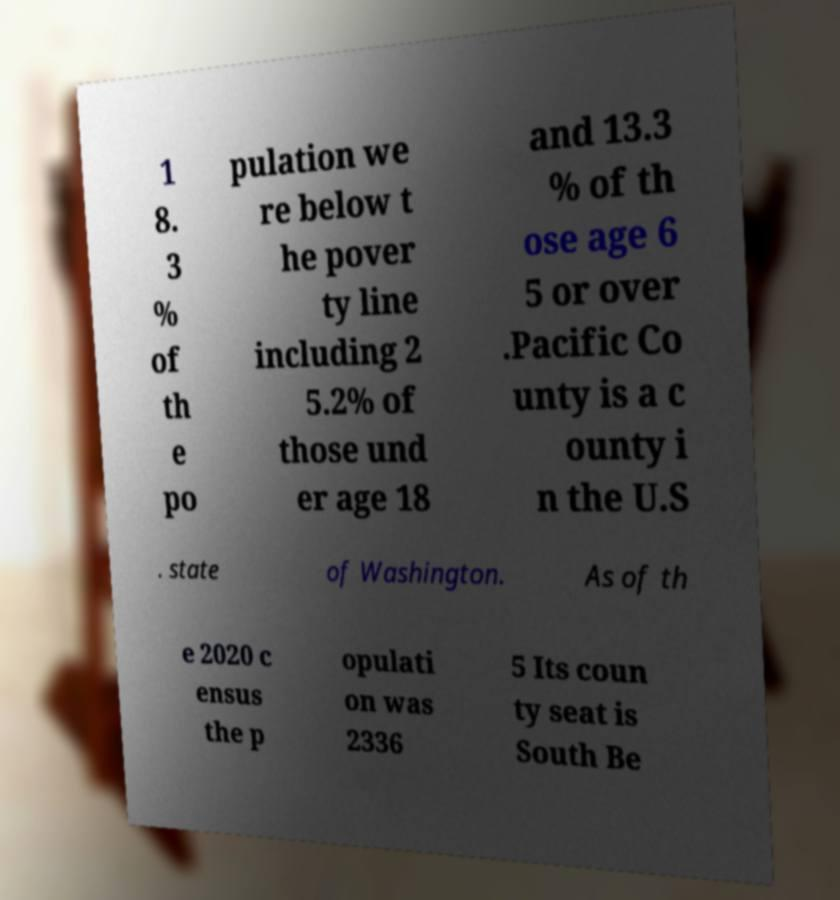Can you accurately transcribe the text from the provided image for me? 1 8. 3 % of th e po pulation we re below t he pover ty line including 2 5.2% of those und er age 18 and 13.3 % of th ose age 6 5 or over .Pacific Co unty is a c ounty i n the U.S . state of Washington. As of th e 2020 c ensus the p opulati on was 2336 5 Its coun ty seat is South Be 